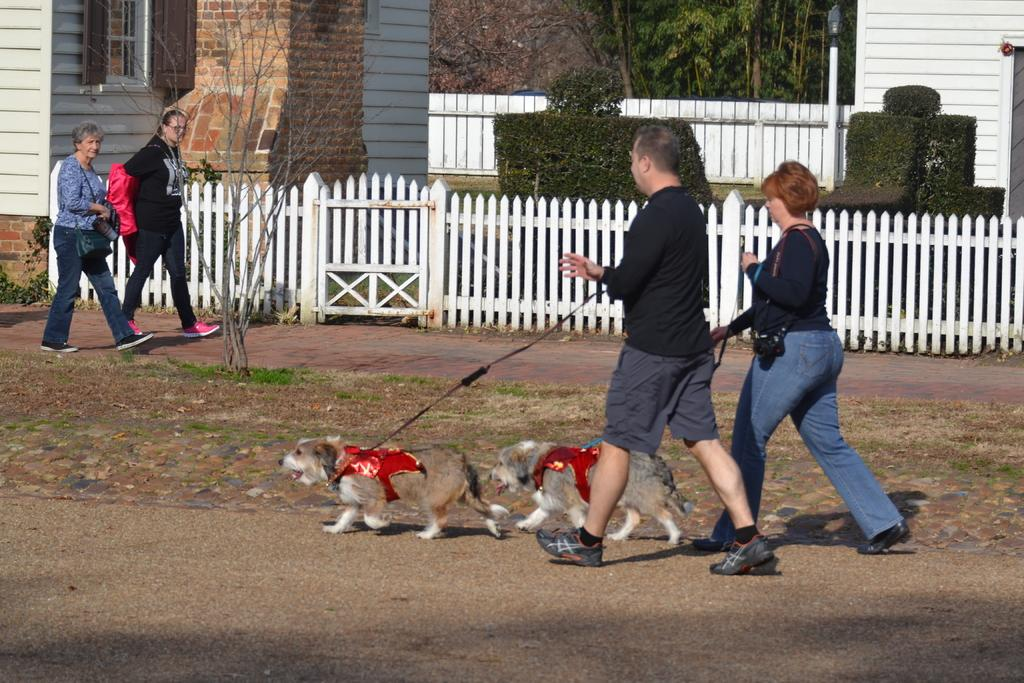How many people are in the image? There are two people in the image, a man and a woman. What are the man and woman doing in the image? The man and woman are holding two dogs with a string. Are there any other people in the image? Yes, there are two women walking in the image. What can be seen in the background of the image? There are buildings and trees visible in the image. What type of toy can be seen on the hill in the image? There is no toy or hill present in the image. What is the woman using to eat her salad in the image? There is no salad or fork present in the image. 